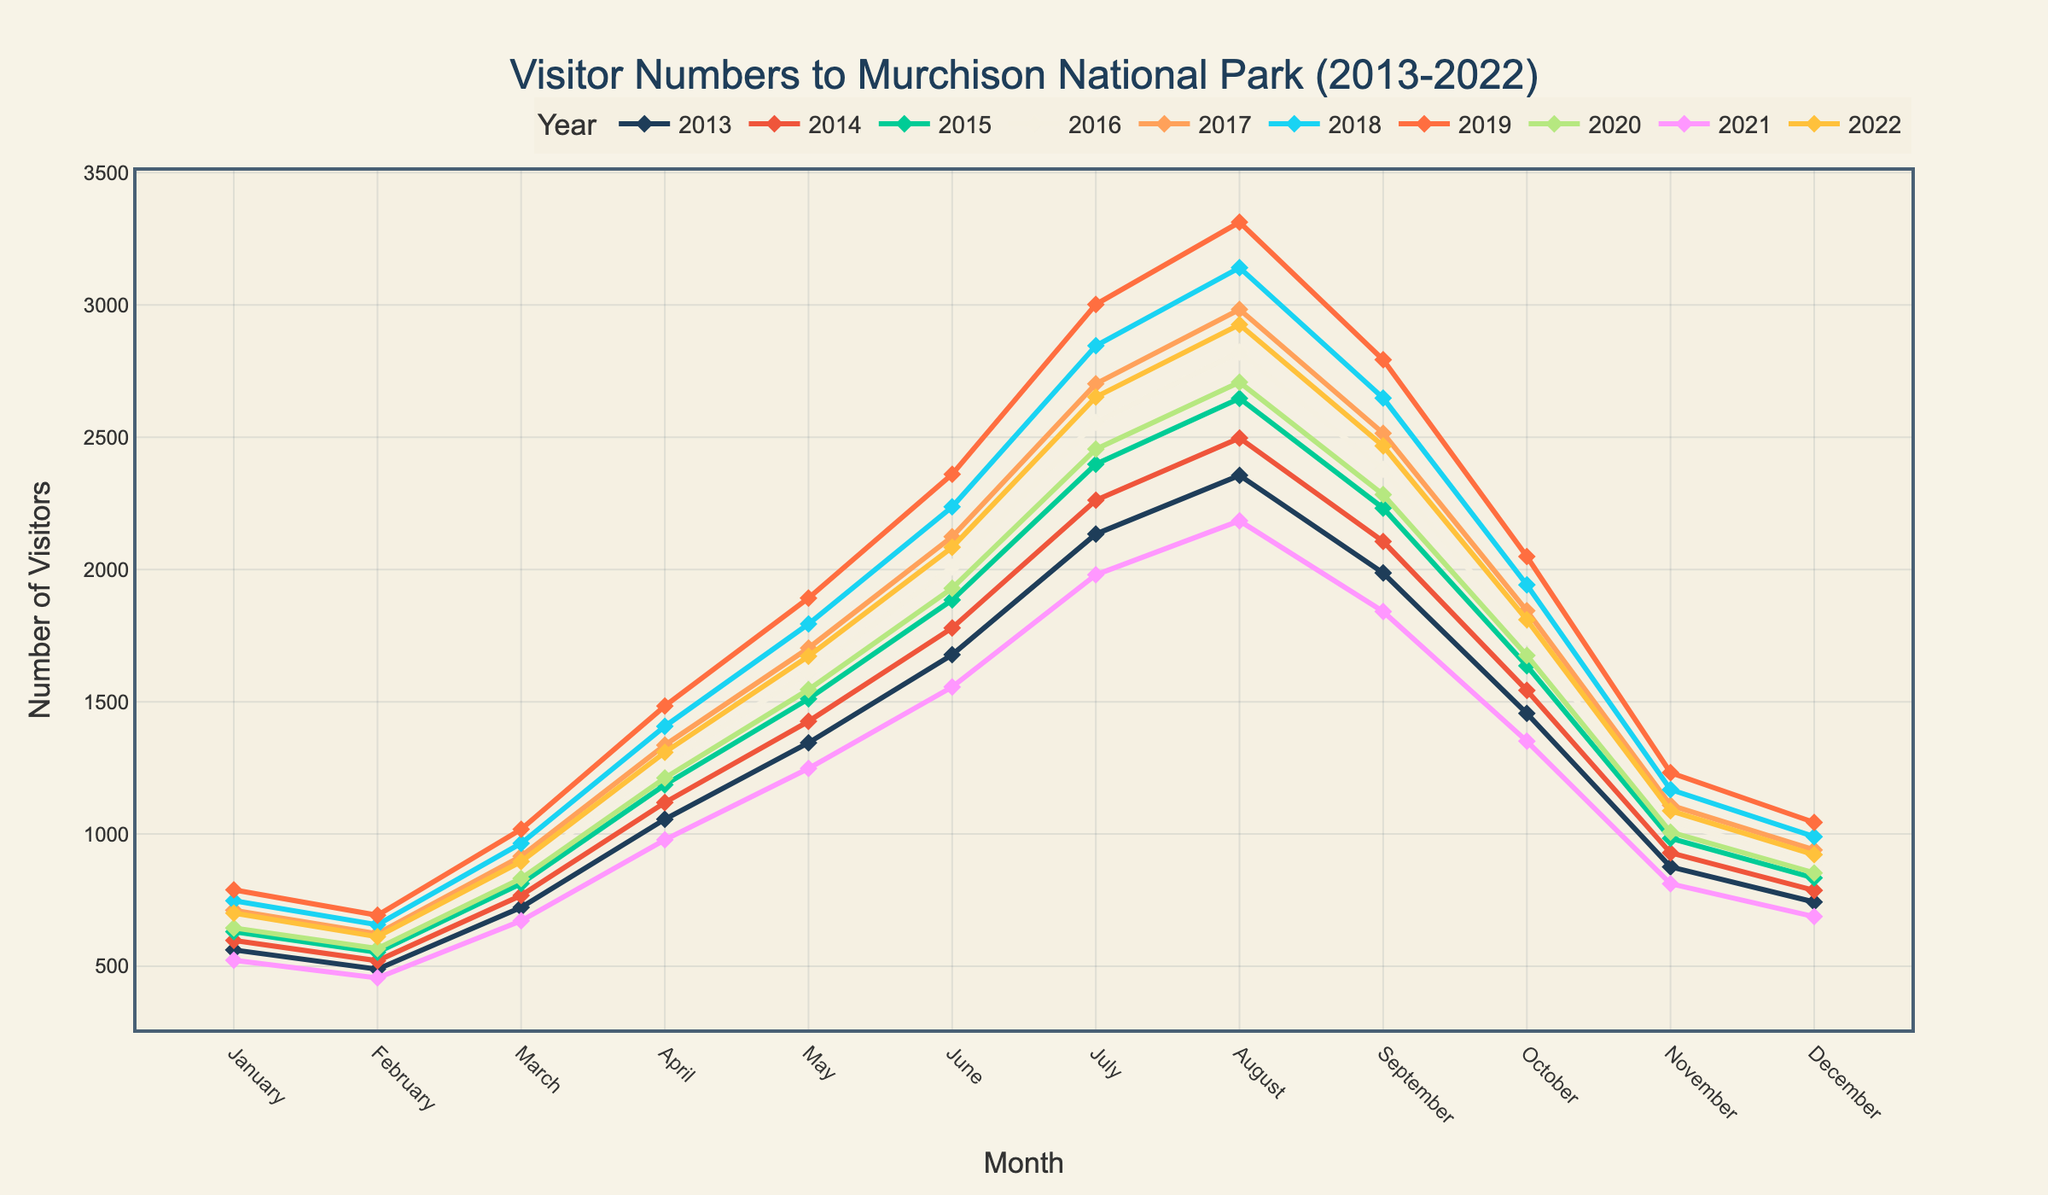What month had the highest number of visitors in 2019? Look for the peak in the 2019 line on the plot. The highest point corresponds to July.
Answer: July Which year showed the highest number of visitors in January? Compare the heights of the markers for January across all years. The highest marker is for the year 2019.
Answer: 2019 Compare visitors in May 2022 and May 2020: which year had more visitors? Look at the markers for May for 2022 and 2020. The marker for 2022 is higher than the one for 2020.
Answer: 2022 Is there a general trend of visitor numbers from January to December each year? Examine the overall slope of the lines from January to December. There is a general trend where visitor numbers typically rise mid-year and decline towards the end.
Answer: Up, then down What was the average number of visitors in July for the decade? Sum the visitor numbers for July over the years: (2134 + 2262 + 2398 + 2556 + 2702 + 2846 + 3002 + 2455 + 1980 + 2652). Divide by 10 to get the average.
Answer: 2498.7 In which month did 2021 see the lowest number of visitors? Find the lowest point on the 2021 line. The lowest number of visitors for 2021 was in December.
Answer: December Which year had the highest overall number of visitors in March? Compare the heights of the March markers across all years. The highest marker is for 2019.
Answer: 2019 How do the visitor numbers in June 2013 compare to June 2022? Compare the heights of the June markers for 2013 and 2022. The marker for 2022 is higher.
Answer: 2022 What is the total number of visitors in September over all recorded years? Sum the September visitor numbers: (1987 + 2106 + 2232 + 2379 + 2515 + 2648 + 2793 + 2283 + 1841 + 2467).
Answer: 23251 